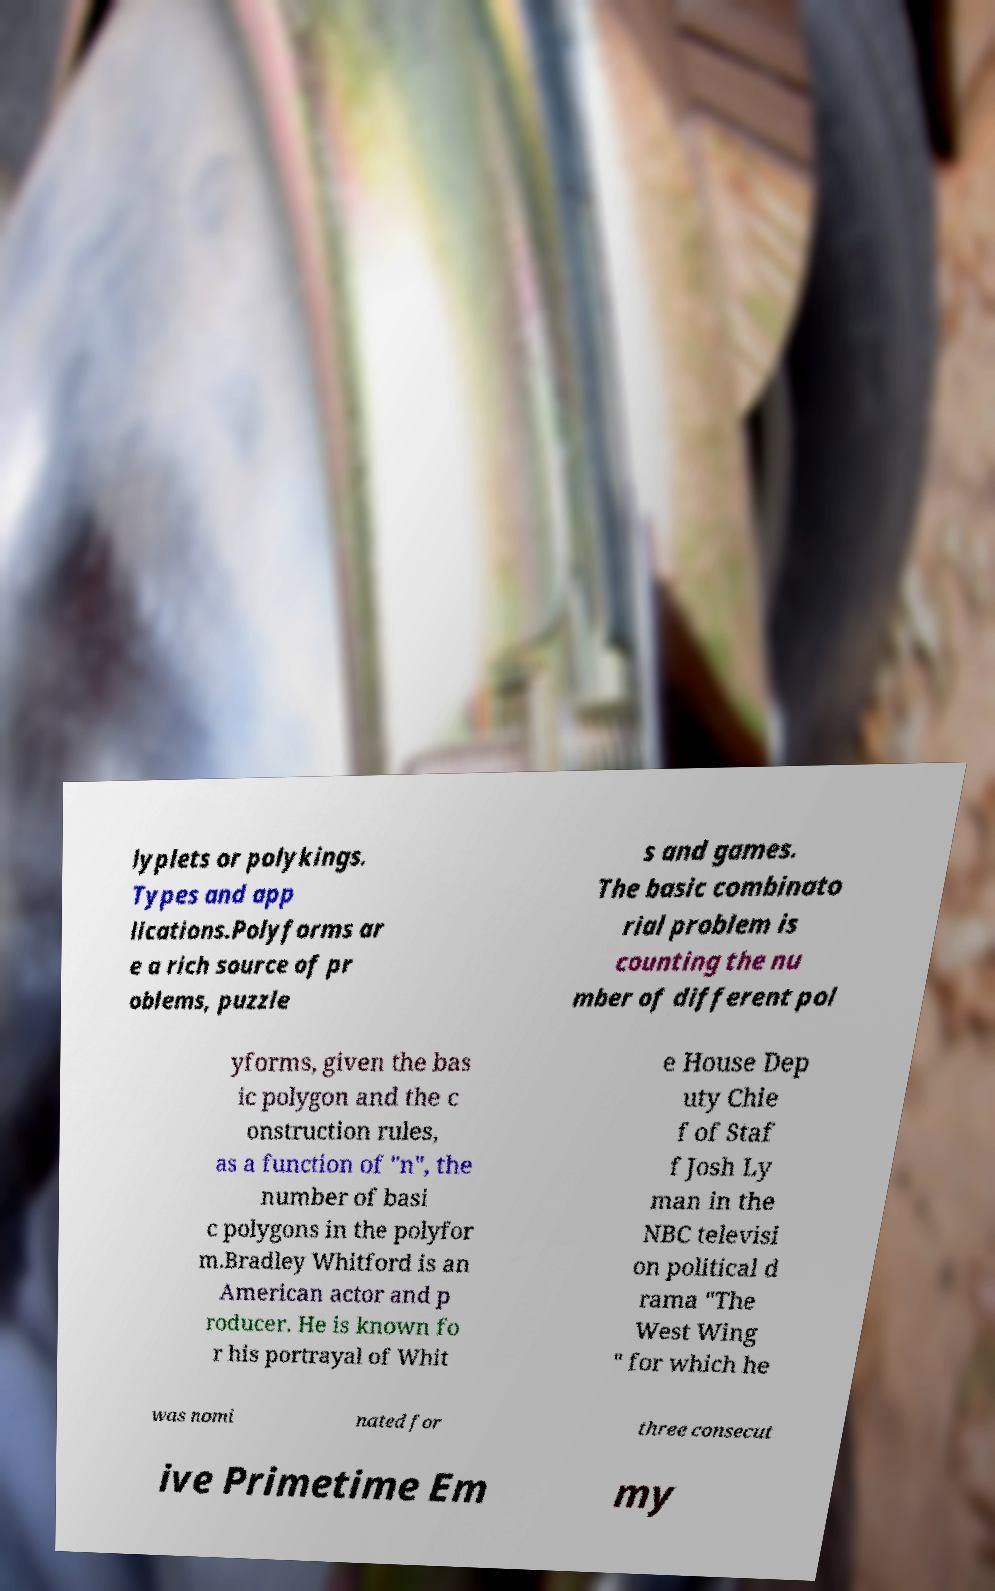Could you assist in decoding the text presented in this image and type it out clearly? lyplets or polykings. Types and app lications.Polyforms ar e a rich source of pr oblems, puzzle s and games. The basic combinato rial problem is counting the nu mber of different pol yforms, given the bas ic polygon and the c onstruction rules, as a function of "n", the number of basi c polygons in the polyfor m.Bradley Whitford is an American actor and p roducer. He is known fo r his portrayal of Whit e House Dep uty Chie f of Staf f Josh Ly man in the NBC televisi on political d rama "The West Wing " for which he was nomi nated for three consecut ive Primetime Em my 